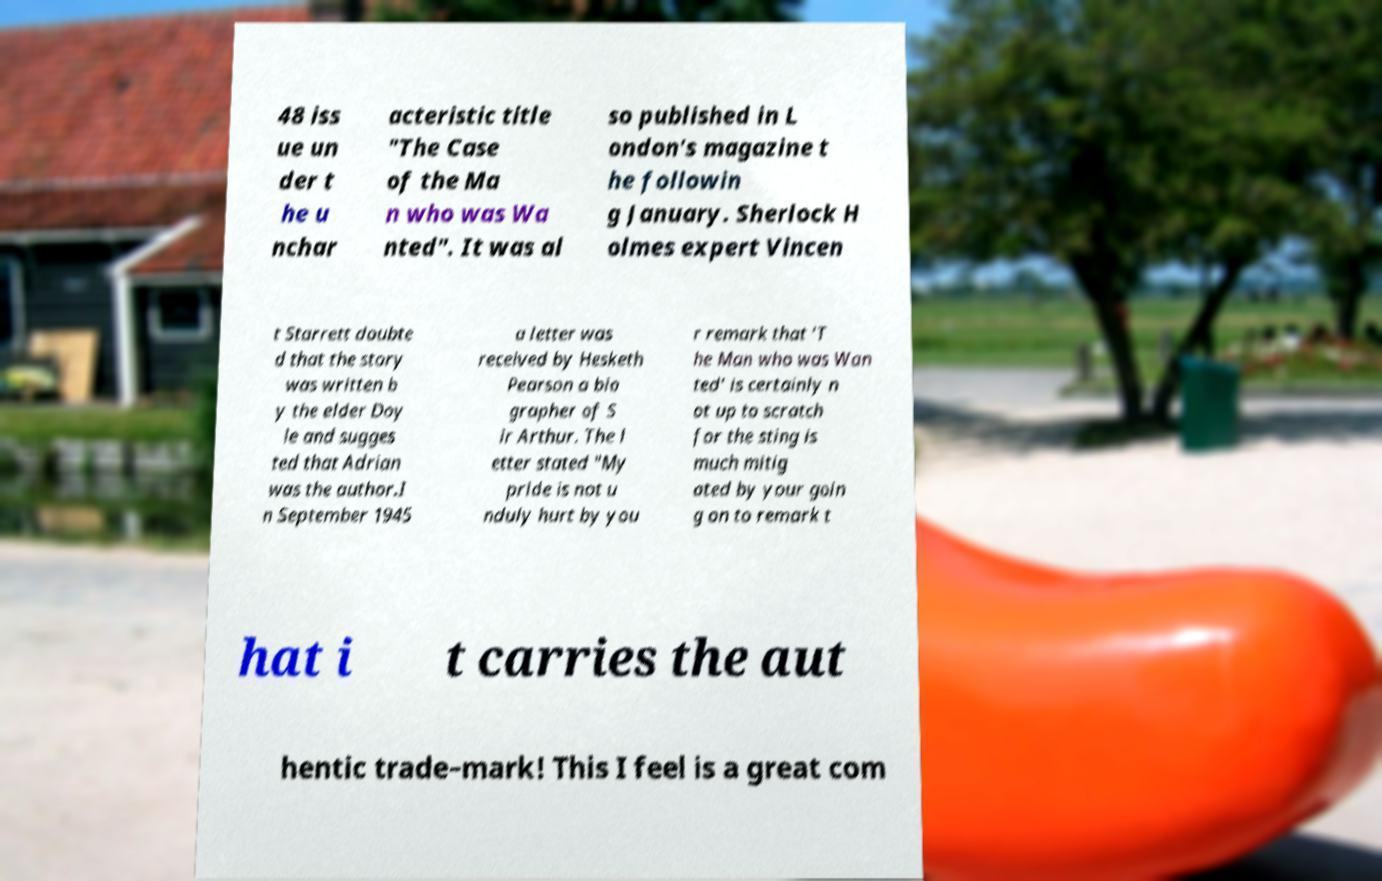Please identify and transcribe the text found in this image. 48 iss ue un der t he u nchar acteristic title "The Case of the Ma n who was Wa nted". It was al so published in L ondon's magazine t he followin g January. Sherlock H olmes expert Vincen t Starrett doubte d that the story was written b y the elder Doy le and sugges ted that Adrian was the author.I n September 1945 a letter was received by Hesketh Pearson a bio grapher of S ir Arthur. The l etter stated "My pride is not u nduly hurt by you r remark that 'T he Man who was Wan ted' is certainly n ot up to scratch for the sting is much mitig ated by your goin g on to remark t hat i t carries the aut hentic trade–mark! This I feel is a great com 